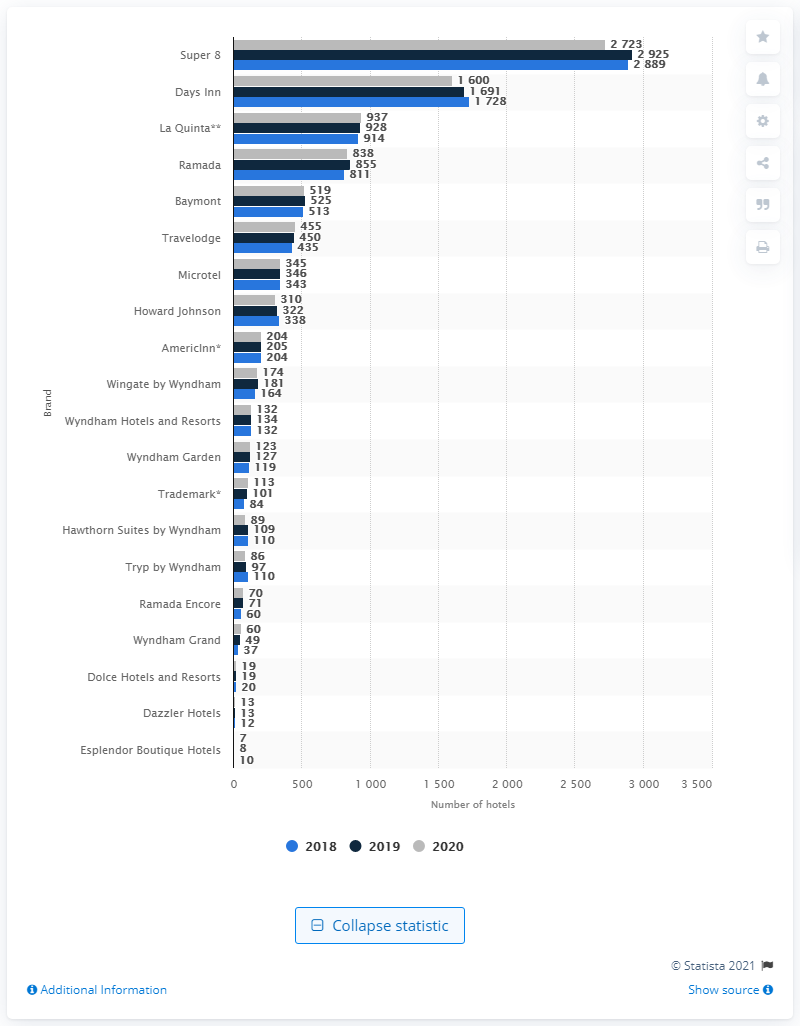Give some essential details in this illustration. In 2020, the hotel brand with the largest number of properties in Wyndham's portfolio was Super 8. In 2020, Days Inn was the hotel chain that had the second largest number of properties in its portfolio. 